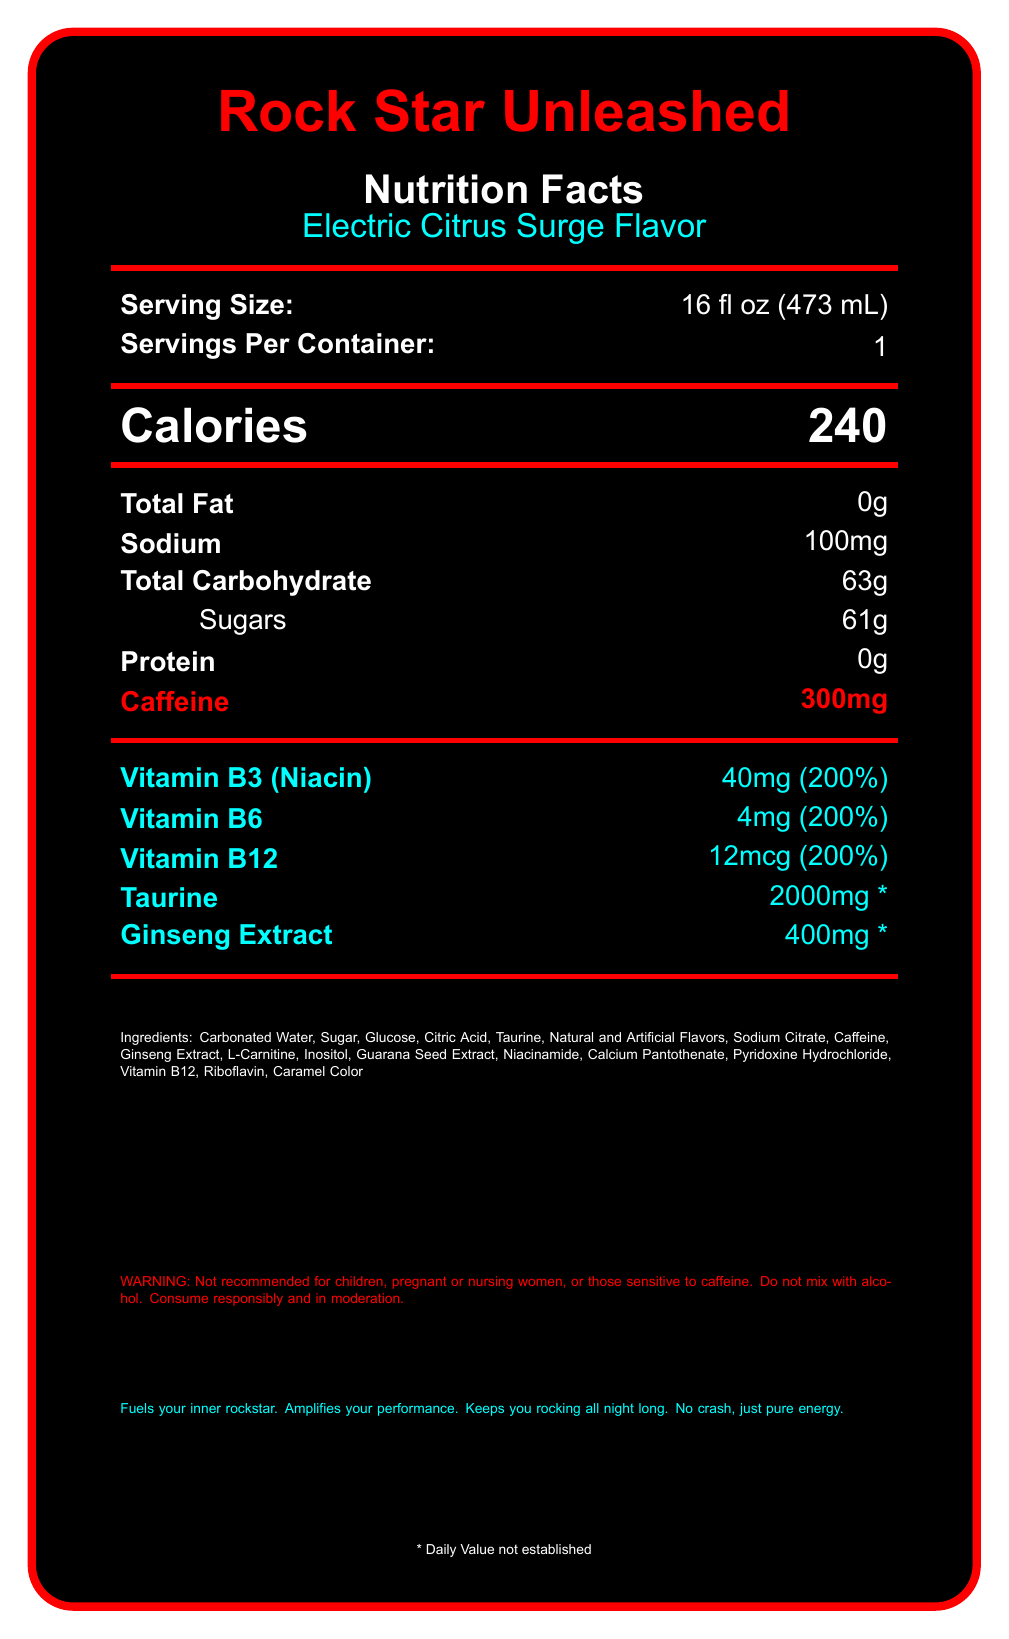what is the serving size? The serving size is listed at the top of the nutrition facts under "Serving Size:".
Answer: 16 fl oz (473 mL) how many calories are in one serving of Rock Star Unleashed? The number of calories is shown clearly next to "Calories" in large font.
Answer: 240 how much caffeine does Rock Star Unleashed contain per serving? The caffeine content is shown next to "Caffeine" in bold and colorful font.
Answer: 300mg what is the total carbohydrate content in Rock Star Unleashed? The total carbohydrate content is listed next to "Total Carbohydrate".
Answer: 63g can Rock Star Unleashed be mixed with alcohol? One of the warnings at the bottom of the document states "Do not mix with alcohol".
Answer: No which vitamin is present in the highest daily value percentage in Rock Star Unleashed? Both Vitamin B3 (Niacin), Vitamin B6, and Vitamin B12 are at 200%, but Vitamin B3 is listed first.
Answer: Vitamin B3 (Niacin) at 200% how many grams of sugar does Rock Star Unleashed have? The sugar content is listed next to "Sugars" under the total carbohydrates.
Answer: 61g what are the main ingredients in Rock Star Unleashed? The ingredients are listed towards the bottom under "Ingredients".
Answer: Carbonated Water, Sugar, Glucose, Citric Acid, Taurine, etc. who is the target audience for Rock Star Unleashed? The target audience is mentioned in the product details.
Answer: Rock music enthusiasts and high-energy individuals which other energy drinks are comparable to Rock Star Unleashed? A. Monster Energy B. Coca-Cola C. Red Bull D. Pepsi The document lists "Monster Energy" and "Red Bull" as comparable products.
Answer: A, C what flavor is Rock Star Unleashed? A. Citrus B. Berry C. Tropical D. Electric Citrus Surge The flavor is described as "Electric Citrus Surge" in the document.
Answer: D is Rock Star Unleashed recommended for children? The document includes a warning specifically stating "Not recommended for children".
Answer: No summarize the main features of Rock Star Unleashed. The document provides comprehensive details regarding serving size, key nutrients, warnings, ingredients, and marketing claims of Rock Star Unleashed.
Answer: Rock Star Unleashed is a high-caffeine energy drink with 240 calories, 300mg of caffeine, and significant amounts of Vitamin B3, B6, and B12. It targets rock music enthusiasts with a unique "Electric Citrus Surge" flavor and high energy ingredients like Taurine and Ginseng Extract. It includes warnings about usage and emphasizes its energizing effects without a crash. what time did the manufacturing process begin for this batch of Rock Star Unleashed? The document does not provide any information about the manufacturing process or specific batch timing.
Answer: Cannot be determined 